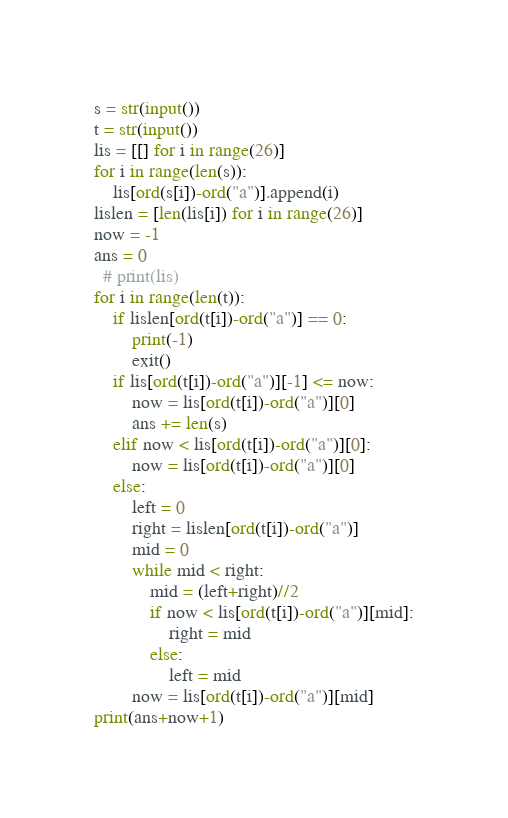<code> <loc_0><loc_0><loc_500><loc_500><_Python_>s = str(input())
t = str(input())
lis = [[] for i in range(26)]
for i in range(len(s)):
    lis[ord(s[i])-ord("a")].append(i)
lislen = [len(lis[i]) for i in range(26)]
now = -1
ans = 0
  # print(lis)
for i in range(len(t)):
    if lislen[ord(t[i])-ord("a")] == 0:
        print(-1)
        exit()
    if lis[ord(t[i])-ord("a")][-1] <= now:
        now = lis[ord(t[i])-ord("a")][0]
        ans += len(s)
    elif now < lis[ord(t[i])-ord("a")][0]:
        now = lis[ord(t[i])-ord("a")][0]
    else:
        left = 0
        right = lislen[ord(t[i])-ord("a")]
        mid = 0
        while mid < right:
            mid = (left+right)//2
            if now < lis[ord(t[i])-ord("a")][mid]:
                right = mid
            else:
                left = mid
        now = lis[ord(t[i])-ord("a")][mid]
print(ans+now+1)</code> 